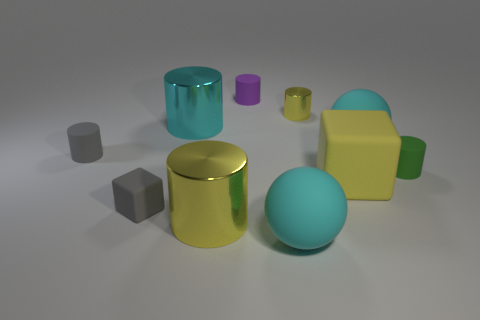Subtract all green cylinders. How many cylinders are left? 5 Subtract all gray cylinders. How many cylinders are left? 5 Subtract all cyan cylinders. Subtract all blue cubes. How many cylinders are left? 5 Subtract all blocks. How many objects are left? 8 Add 1 cyan metallic things. How many cyan metallic things are left? 2 Add 1 large yellow shiny cylinders. How many large yellow shiny cylinders exist? 2 Subtract 0 red spheres. How many objects are left? 10 Subtract all large metal cylinders. Subtract all cyan metallic cylinders. How many objects are left? 7 